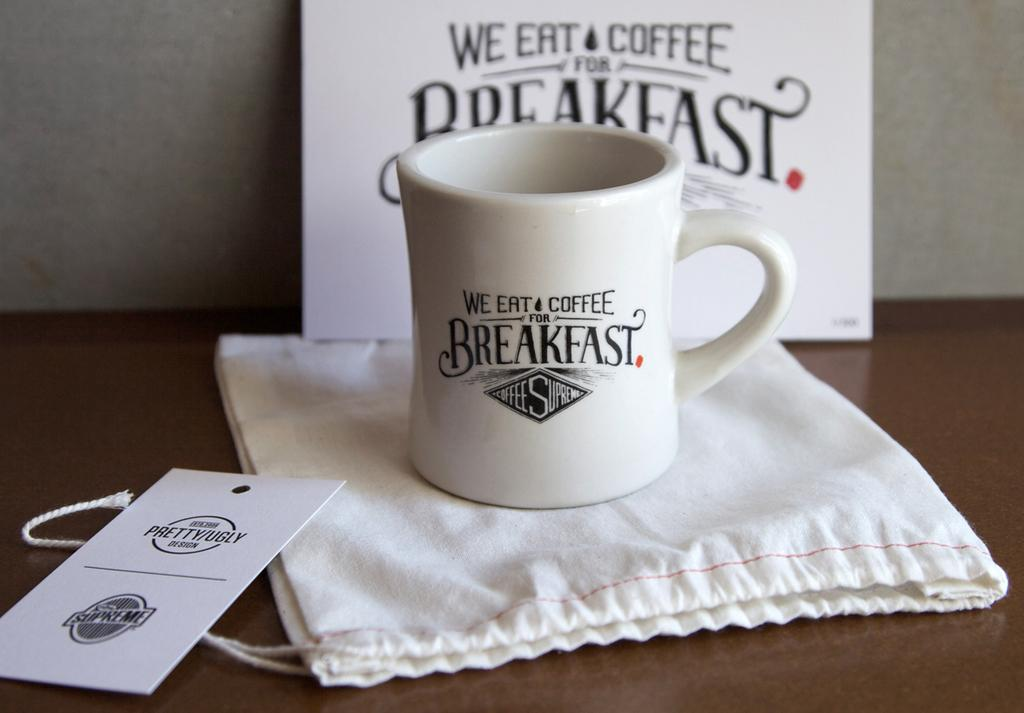<image>
Present a compact description of the photo's key features. A product display on a table with a mug that say We Eat & Coffee for Breakfast. 